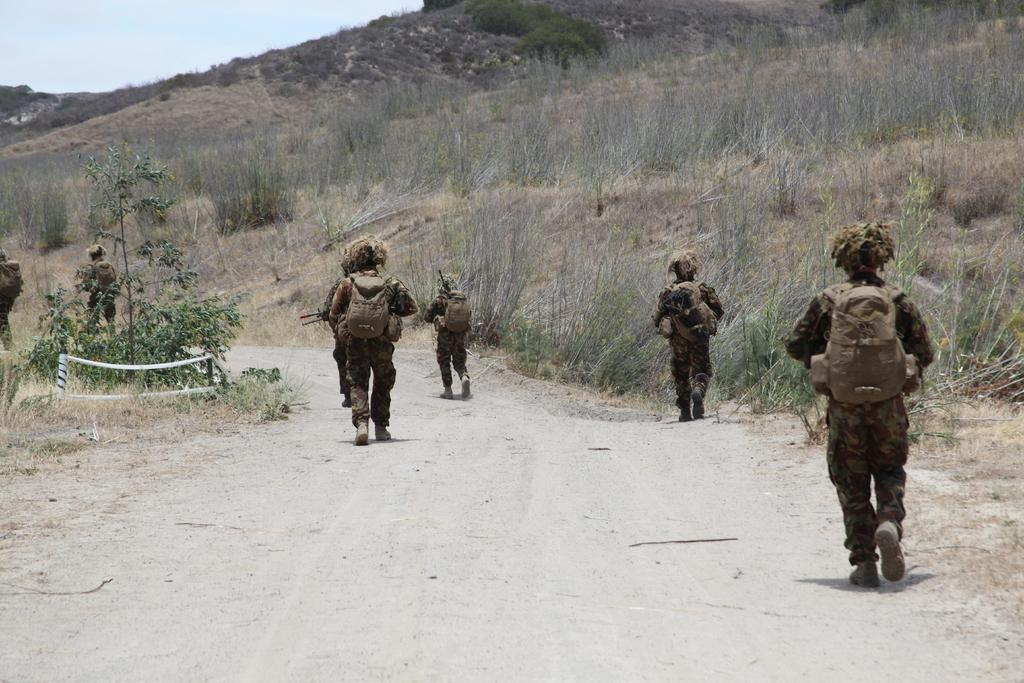Who or what can be seen in the image? There are people in the image. What are the people wearing? The people are wearing bags. What are the people doing in the image? The people are walking on a pathway. What type of vegetation can be seen in the image? There are plants visible in the image. What is the landscape feature in the background of the image? There are trees on a hill in the image. What is visible above the people and landscape? The sky is visible in the image. What type of ear can be seen on the people in the image? There is no specific type of ear mentioned or visible in the image; the people are wearing bags. What story is being told by the people in the image? There is no story being told in the image; it simply shows people walking on a pathway. 